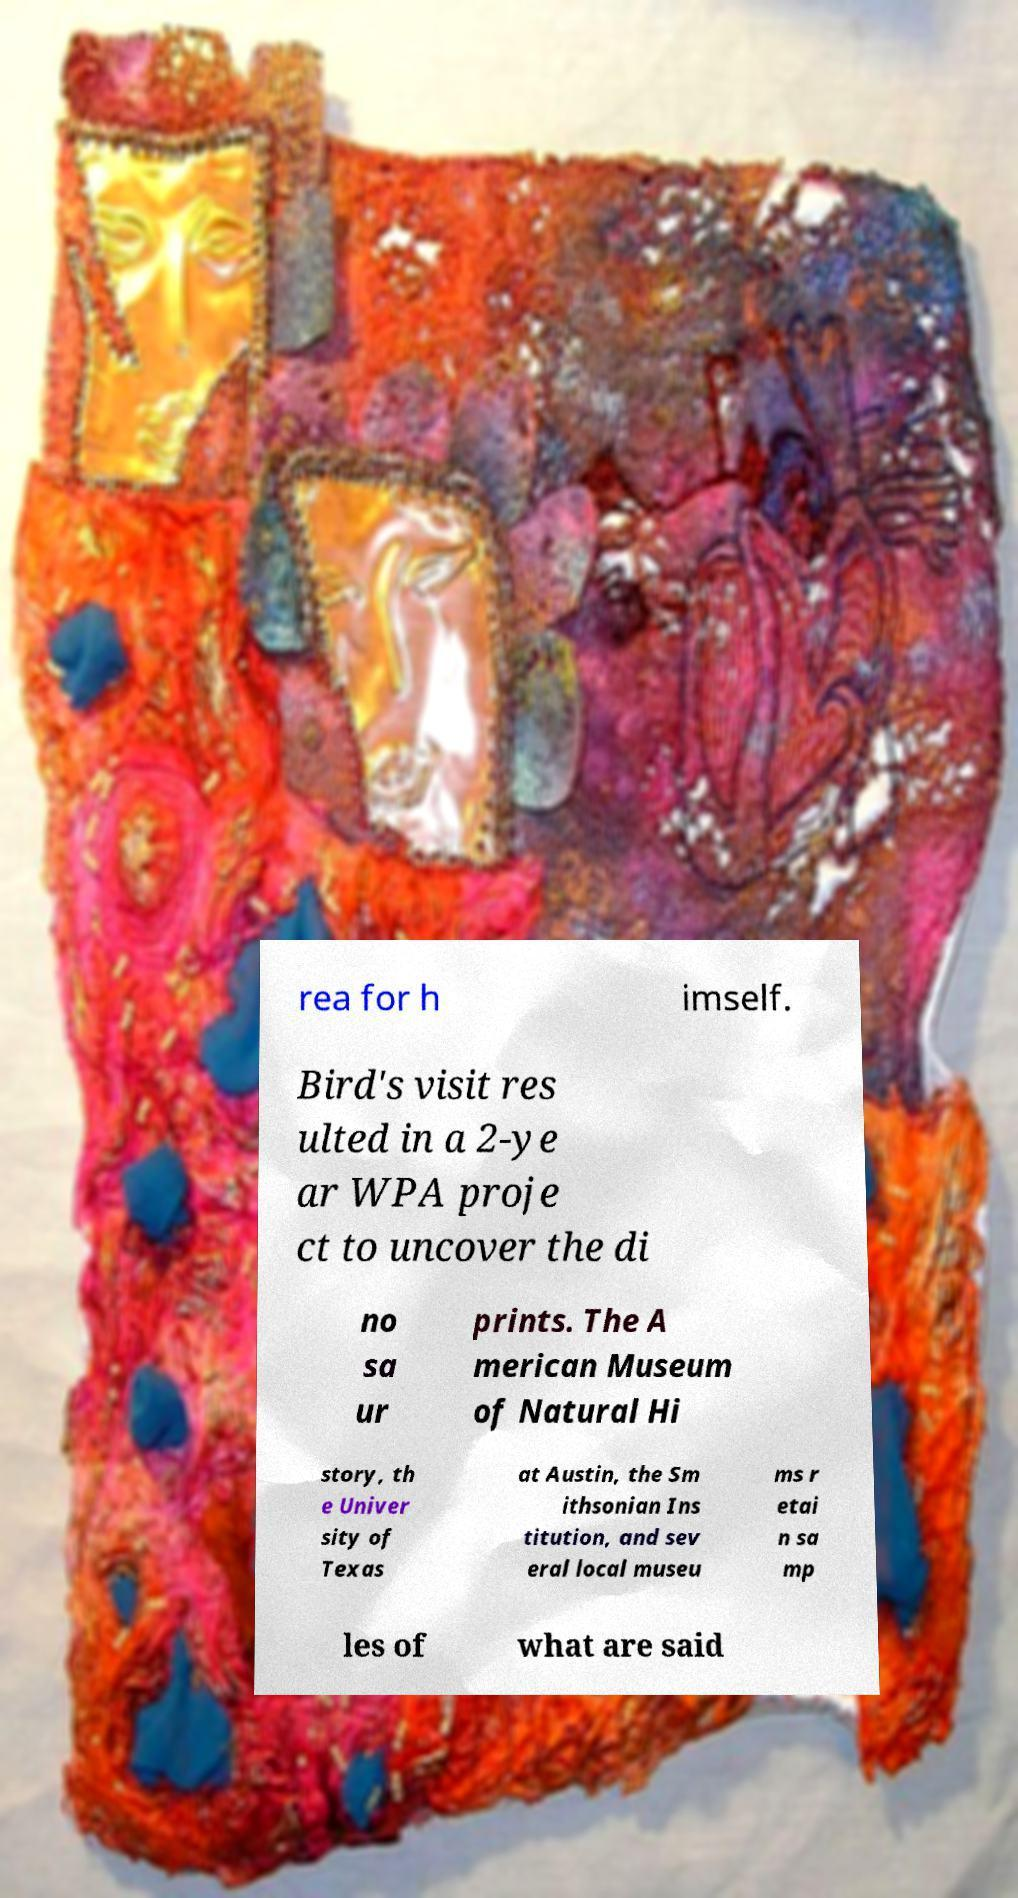What messages or text are displayed in this image? I need them in a readable, typed format. rea for h imself. Bird's visit res ulted in a 2-ye ar WPA proje ct to uncover the di no sa ur prints. The A merican Museum of Natural Hi story, th e Univer sity of Texas at Austin, the Sm ithsonian Ins titution, and sev eral local museu ms r etai n sa mp les of what are said 